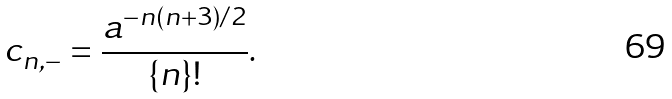<formula> <loc_0><loc_0><loc_500><loc_500>c _ { n , - } = \frac { a ^ { - n ( n + 3 ) / 2 } } { \{ n \} ! } .</formula> 